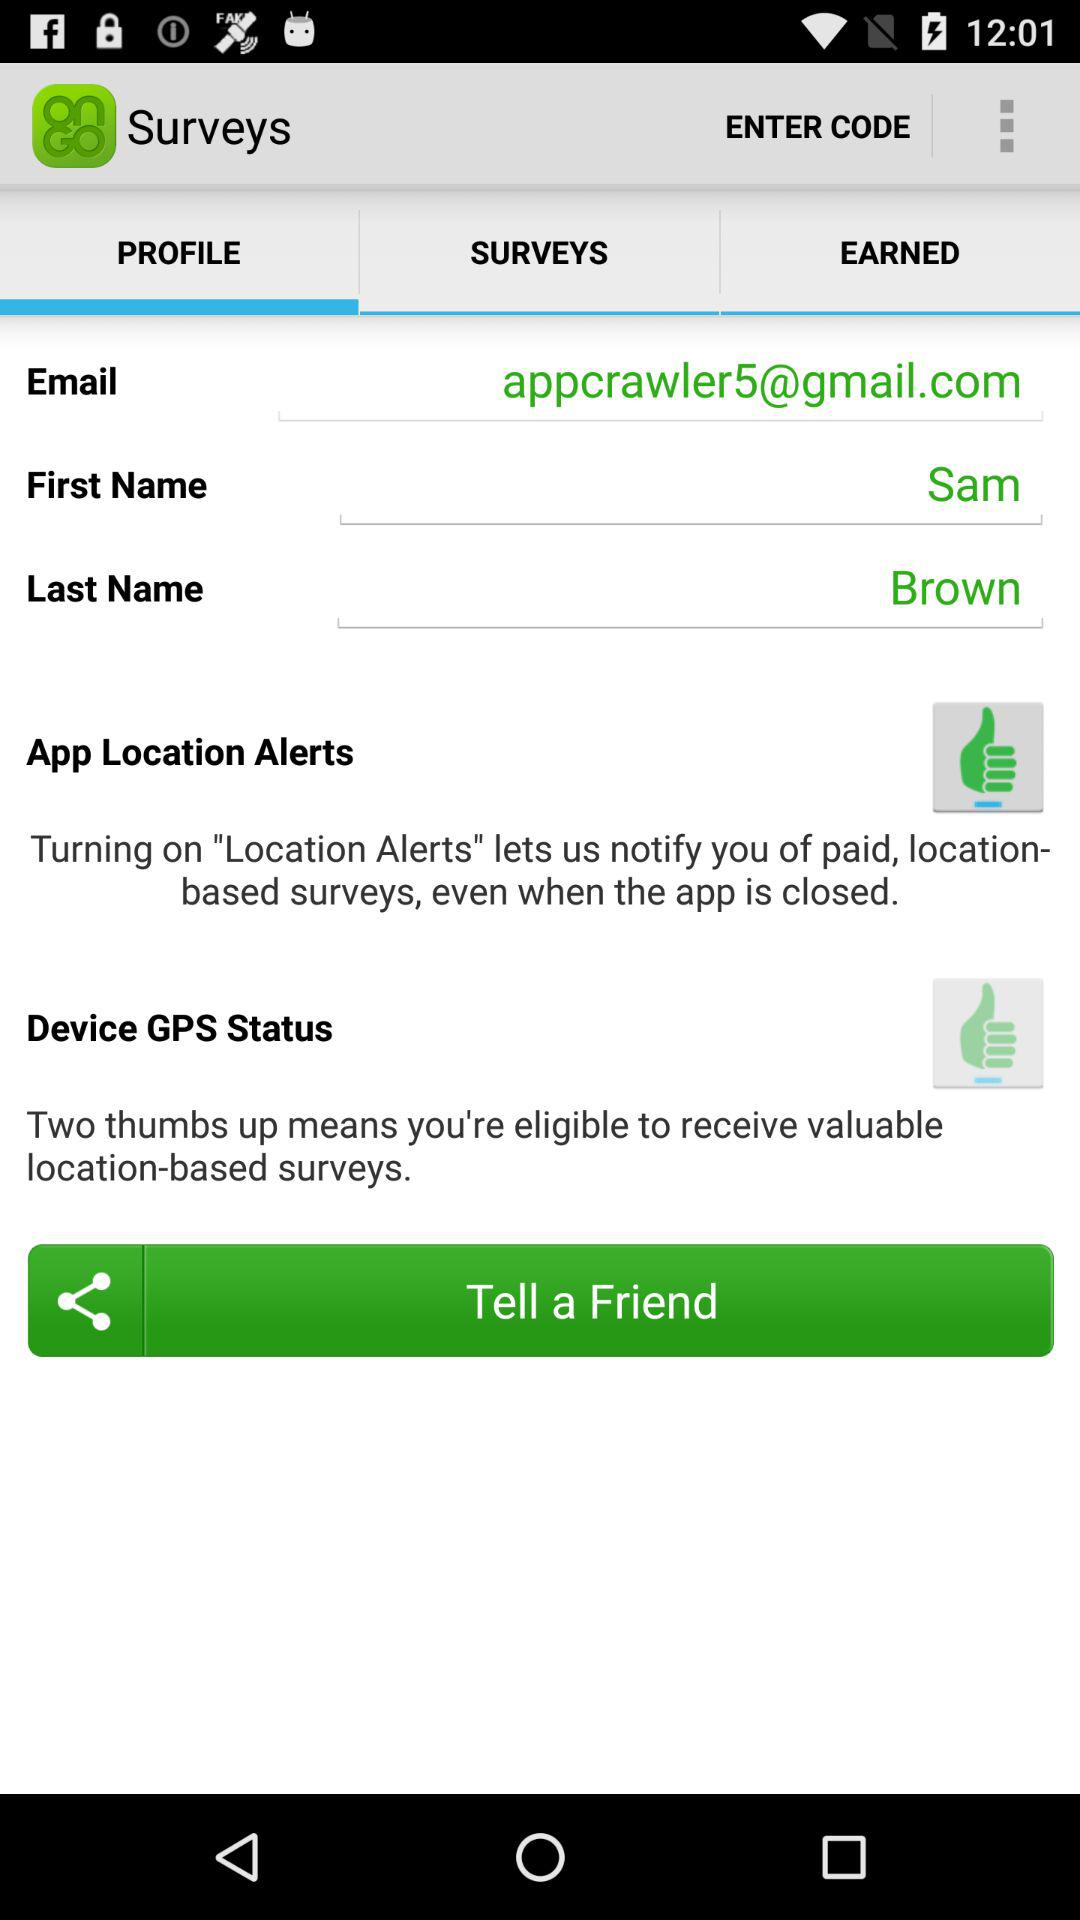What is the first name? The first name is Sam. 